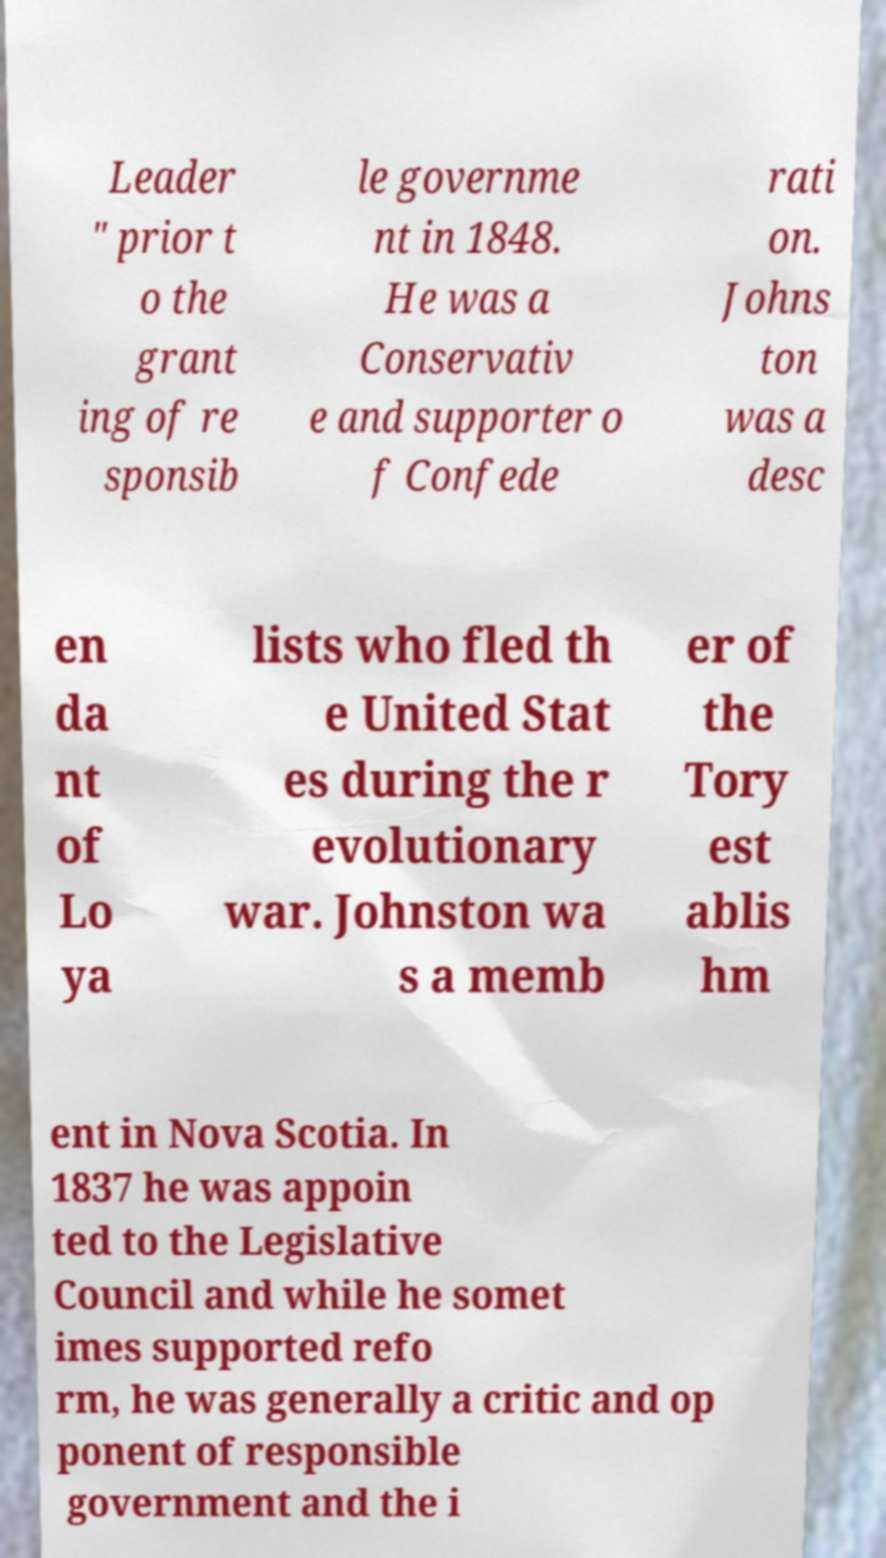Can you accurately transcribe the text from the provided image for me? Leader " prior t o the grant ing of re sponsib le governme nt in 1848. He was a Conservativ e and supporter o f Confede rati on. Johns ton was a desc en da nt of Lo ya lists who fled th e United Stat es during the r evolutionary war. Johnston wa s a memb er of the Tory est ablis hm ent in Nova Scotia. In 1837 he was appoin ted to the Legislative Council and while he somet imes supported refo rm, he was generally a critic and op ponent of responsible government and the i 